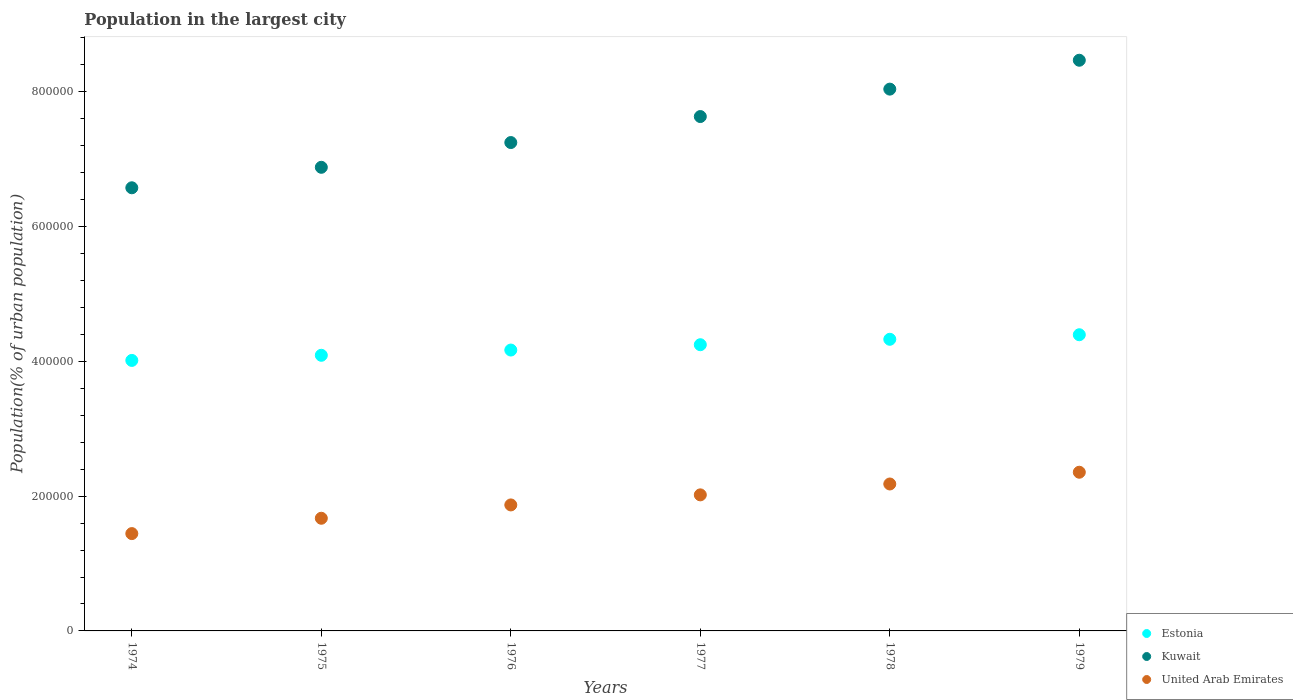How many different coloured dotlines are there?
Your response must be concise. 3. What is the population in the largest city in Kuwait in 1976?
Provide a succinct answer. 7.25e+05. Across all years, what is the maximum population in the largest city in Estonia?
Offer a very short reply. 4.40e+05. Across all years, what is the minimum population in the largest city in Estonia?
Your response must be concise. 4.01e+05. In which year was the population in the largest city in Kuwait maximum?
Offer a terse response. 1979. In which year was the population in the largest city in Estonia minimum?
Ensure brevity in your answer.  1974. What is the total population in the largest city in Estonia in the graph?
Your response must be concise. 2.52e+06. What is the difference between the population in the largest city in United Arab Emirates in 1976 and that in 1978?
Give a very brief answer. -3.11e+04. What is the difference between the population in the largest city in Kuwait in 1978 and the population in the largest city in United Arab Emirates in 1976?
Give a very brief answer. 6.17e+05. What is the average population in the largest city in Estonia per year?
Offer a very short reply. 4.21e+05. In the year 1979, what is the difference between the population in the largest city in Estonia and population in the largest city in United Arab Emirates?
Ensure brevity in your answer.  2.04e+05. In how many years, is the population in the largest city in Estonia greater than 200000 %?
Keep it short and to the point. 6. What is the ratio of the population in the largest city in Kuwait in 1976 to that in 1977?
Give a very brief answer. 0.95. What is the difference between the highest and the second highest population in the largest city in Estonia?
Offer a terse response. 6750. What is the difference between the highest and the lowest population in the largest city in Kuwait?
Provide a short and direct response. 1.89e+05. In how many years, is the population in the largest city in United Arab Emirates greater than the average population in the largest city in United Arab Emirates taken over all years?
Your response must be concise. 3. Is it the case that in every year, the sum of the population in the largest city in Kuwait and population in the largest city in United Arab Emirates  is greater than the population in the largest city in Estonia?
Your answer should be compact. Yes. Does the population in the largest city in Estonia monotonically increase over the years?
Your answer should be very brief. Yes. Is the population in the largest city in Kuwait strictly greater than the population in the largest city in Estonia over the years?
Your answer should be compact. Yes. How many dotlines are there?
Make the answer very short. 3. What is the difference between two consecutive major ticks on the Y-axis?
Give a very brief answer. 2.00e+05. Does the graph contain any zero values?
Keep it short and to the point. No. Does the graph contain grids?
Your answer should be compact. No. How are the legend labels stacked?
Ensure brevity in your answer.  Vertical. What is the title of the graph?
Keep it short and to the point. Population in the largest city. Does "Switzerland" appear as one of the legend labels in the graph?
Your answer should be compact. No. What is the label or title of the X-axis?
Offer a very short reply. Years. What is the label or title of the Y-axis?
Offer a very short reply. Population(% of urban population). What is the Population(% of urban population) in Estonia in 1974?
Make the answer very short. 4.01e+05. What is the Population(% of urban population) of Kuwait in 1974?
Your answer should be compact. 6.58e+05. What is the Population(% of urban population) of United Arab Emirates in 1974?
Give a very brief answer. 1.44e+05. What is the Population(% of urban population) in Estonia in 1975?
Give a very brief answer. 4.09e+05. What is the Population(% of urban population) of Kuwait in 1975?
Offer a terse response. 6.88e+05. What is the Population(% of urban population) in United Arab Emirates in 1975?
Give a very brief answer. 1.67e+05. What is the Population(% of urban population) in Estonia in 1976?
Offer a very short reply. 4.17e+05. What is the Population(% of urban population) in Kuwait in 1976?
Ensure brevity in your answer.  7.25e+05. What is the Population(% of urban population) of United Arab Emirates in 1976?
Offer a terse response. 1.87e+05. What is the Population(% of urban population) in Estonia in 1977?
Give a very brief answer. 4.25e+05. What is the Population(% of urban population) of Kuwait in 1977?
Provide a short and direct response. 7.63e+05. What is the Population(% of urban population) of United Arab Emirates in 1977?
Give a very brief answer. 2.02e+05. What is the Population(% of urban population) of Estonia in 1978?
Your answer should be compact. 4.33e+05. What is the Population(% of urban population) of Kuwait in 1978?
Offer a terse response. 8.04e+05. What is the Population(% of urban population) of United Arab Emirates in 1978?
Your answer should be very brief. 2.18e+05. What is the Population(% of urban population) in Estonia in 1979?
Ensure brevity in your answer.  4.40e+05. What is the Population(% of urban population) of Kuwait in 1979?
Make the answer very short. 8.47e+05. What is the Population(% of urban population) of United Arab Emirates in 1979?
Your response must be concise. 2.36e+05. Across all years, what is the maximum Population(% of urban population) of Estonia?
Your response must be concise. 4.40e+05. Across all years, what is the maximum Population(% of urban population) in Kuwait?
Provide a short and direct response. 8.47e+05. Across all years, what is the maximum Population(% of urban population) of United Arab Emirates?
Provide a short and direct response. 2.36e+05. Across all years, what is the minimum Population(% of urban population) of Estonia?
Provide a succinct answer. 4.01e+05. Across all years, what is the minimum Population(% of urban population) of Kuwait?
Ensure brevity in your answer.  6.58e+05. Across all years, what is the minimum Population(% of urban population) of United Arab Emirates?
Make the answer very short. 1.44e+05. What is the total Population(% of urban population) of Estonia in the graph?
Your answer should be very brief. 2.52e+06. What is the total Population(% of urban population) of Kuwait in the graph?
Make the answer very short. 4.48e+06. What is the total Population(% of urban population) of United Arab Emirates in the graph?
Make the answer very short. 1.15e+06. What is the difference between the Population(% of urban population) of Estonia in 1974 and that in 1975?
Your answer should be very brief. -7622. What is the difference between the Population(% of urban population) in Kuwait in 1974 and that in 1975?
Offer a very short reply. -3.04e+04. What is the difference between the Population(% of urban population) in United Arab Emirates in 1974 and that in 1975?
Provide a short and direct response. -2.28e+04. What is the difference between the Population(% of urban population) in Estonia in 1974 and that in 1976?
Give a very brief answer. -1.54e+04. What is the difference between the Population(% of urban population) in Kuwait in 1974 and that in 1976?
Your response must be concise. -6.71e+04. What is the difference between the Population(% of urban population) of United Arab Emirates in 1974 and that in 1976?
Offer a very short reply. -4.25e+04. What is the difference between the Population(% of urban population) of Estonia in 1974 and that in 1977?
Keep it short and to the point. -2.33e+04. What is the difference between the Population(% of urban population) of Kuwait in 1974 and that in 1977?
Provide a short and direct response. -1.06e+05. What is the difference between the Population(% of urban population) in United Arab Emirates in 1974 and that in 1977?
Make the answer very short. -5.75e+04. What is the difference between the Population(% of urban population) in Estonia in 1974 and that in 1978?
Ensure brevity in your answer.  -3.14e+04. What is the difference between the Population(% of urban population) in Kuwait in 1974 and that in 1978?
Offer a very short reply. -1.46e+05. What is the difference between the Population(% of urban population) in United Arab Emirates in 1974 and that in 1978?
Offer a very short reply. -7.36e+04. What is the difference between the Population(% of urban population) of Estonia in 1974 and that in 1979?
Give a very brief answer. -3.81e+04. What is the difference between the Population(% of urban population) of Kuwait in 1974 and that in 1979?
Your response must be concise. -1.89e+05. What is the difference between the Population(% of urban population) in United Arab Emirates in 1974 and that in 1979?
Provide a succinct answer. -9.11e+04. What is the difference between the Population(% of urban population) in Estonia in 1975 and that in 1976?
Offer a very short reply. -7777. What is the difference between the Population(% of urban population) in Kuwait in 1975 and that in 1976?
Provide a short and direct response. -3.67e+04. What is the difference between the Population(% of urban population) of United Arab Emirates in 1975 and that in 1976?
Your answer should be very brief. -1.98e+04. What is the difference between the Population(% of urban population) in Estonia in 1975 and that in 1977?
Provide a succinct answer. -1.57e+04. What is the difference between the Population(% of urban population) in Kuwait in 1975 and that in 1977?
Your response must be concise. -7.53e+04. What is the difference between the Population(% of urban population) of United Arab Emirates in 1975 and that in 1977?
Make the answer very short. -3.47e+04. What is the difference between the Population(% of urban population) of Estonia in 1975 and that in 1978?
Your answer should be very brief. -2.37e+04. What is the difference between the Population(% of urban population) of Kuwait in 1975 and that in 1978?
Offer a very short reply. -1.16e+05. What is the difference between the Population(% of urban population) in United Arab Emirates in 1975 and that in 1978?
Keep it short and to the point. -5.09e+04. What is the difference between the Population(% of urban population) in Estonia in 1975 and that in 1979?
Offer a very short reply. -3.05e+04. What is the difference between the Population(% of urban population) of Kuwait in 1975 and that in 1979?
Offer a terse response. -1.59e+05. What is the difference between the Population(% of urban population) in United Arab Emirates in 1975 and that in 1979?
Your answer should be compact. -6.83e+04. What is the difference between the Population(% of urban population) of Estonia in 1976 and that in 1977?
Provide a succinct answer. -7904. What is the difference between the Population(% of urban population) in Kuwait in 1976 and that in 1977?
Your response must be concise. -3.86e+04. What is the difference between the Population(% of urban population) in United Arab Emirates in 1976 and that in 1977?
Keep it short and to the point. -1.49e+04. What is the difference between the Population(% of urban population) in Estonia in 1976 and that in 1978?
Offer a terse response. -1.60e+04. What is the difference between the Population(% of urban population) of Kuwait in 1976 and that in 1978?
Provide a short and direct response. -7.93e+04. What is the difference between the Population(% of urban population) of United Arab Emirates in 1976 and that in 1978?
Your answer should be very brief. -3.11e+04. What is the difference between the Population(% of urban population) in Estonia in 1976 and that in 1979?
Offer a very short reply. -2.27e+04. What is the difference between the Population(% of urban population) in Kuwait in 1976 and that in 1979?
Ensure brevity in your answer.  -1.22e+05. What is the difference between the Population(% of urban population) in United Arab Emirates in 1976 and that in 1979?
Ensure brevity in your answer.  -4.85e+04. What is the difference between the Population(% of urban population) in Estonia in 1977 and that in 1978?
Offer a very short reply. -8064. What is the difference between the Population(% of urban population) of Kuwait in 1977 and that in 1978?
Provide a short and direct response. -4.07e+04. What is the difference between the Population(% of urban population) in United Arab Emirates in 1977 and that in 1978?
Your response must be concise. -1.61e+04. What is the difference between the Population(% of urban population) in Estonia in 1977 and that in 1979?
Provide a succinct answer. -1.48e+04. What is the difference between the Population(% of urban population) of Kuwait in 1977 and that in 1979?
Provide a succinct answer. -8.36e+04. What is the difference between the Population(% of urban population) of United Arab Emirates in 1977 and that in 1979?
Your answer should be very brief. -3.36e+04. What is the difference between the Population(% of urban population) in Estonia in 1978 and that in 1979?
Your answer should be very brief. -6750. What is the difference between the Population(% of urban population) of Kuwait in 1978 and that in 1979?
Keep it short and to the point. -4.29e+04. What is the difference between the Population(% of urban population) in United Arab Emirates in 1978 and that in 1979?
Offer a very short reply. -1.74e+04. What is the difference between the Population(% of urban population) in Estonia in 1974 and the Population(% of urban population) in Kuwait in 1975?
Make the answer very short. -2.87e+05. What is the difference between the Population(% of urban population) of Estonia in 1974 and the Population(% of urban population) of United Arab Emirates in 1975?
Your answer should be compact. 2.34e+05. What is the difference between the Population(% of urban population) of Kuwait in 1974 and the Population(% of urban population) of United Arab Emirates in 1975?
Your answer should be very brief. 4.90e+05. What is the difference between the Population(% of urban population) of Estonia in 1974 and the Population(% of urban population) of Kuwait in 1976?
Your answer should be very brief. -3.23e+05. What is the difference between the Population(% of urban population) in Estonia in 1974 and the Population(% of urban population) in United Arab Emirates in 1976?
Your response must be concise. 2.14e+05. What is the difference between the Population(% of urban population) in Kuwait in 1974 and the Population(% of urban population) in United Arab Emirates in 1976?
Offer a terse response. 4.71e+05. What is the difference between the Population(% of urban population) of Estonia in 1974 and the Population(% of urban population) of Kuwait in 1977?
Your answer should be very brief. -3.62e+05. What is the difference between the Population(% of urban population) in Estonia in 1974 and the Population(% of urban population) in United Arab Emirates in 1977?
Give a very brief answer. 2.00e+05. What is the difference between the Population(% of urban population) in Kuwait in 1974 and the Population(% of urban population) in United Arab Emirates in 1977?
Offer a very short reply. 4.56e+05. What is the difference between the Population(% of urban population) in Estonia in 1974 and the Population(% of urban population) in Kuwait in 1978?
Your answer should be compact. -4.03e+05. What is the difference between the Population(% of urban population) in Estonia in 1974 and the Population(% of urban population) in United Arab Emirates in 1978?
Ensure brevity in your answer.  1.83e+05. What is the difference between the Population(% of urban population) in Kuwait in 1974 and the Population(% of urban population) in United Arab Emirates in 1978?
Provide a succinct answer. 4.40e+05. What is the difference between the Population(% of urban population) of Estonia in 1974 and the Population(% of urban population) of Kuwait in 1979?
Your response must be concise. -4.45e+05. What is the difference between the Population(% of urban population) in Estonia in 1974 and the Population(% of urban population) in United Arab Emirates in 1979?
Keep it short and to the point. 1.66e+05. What is the difference between the Population(% of urban population) in Kuwait in 1974 and the Population(% of urban population) in United Arab Emirates in 1979?
Keep it short and to the point. 4.22e+05. What is the difference between the Population(% of urban population) of Estonia in 1975 and the Population(% of urban population) of Kuwait in 1976?
Give a very brief answer. -3.16e+05. What is the difference between the Population(% of urban population) in Estonia in 1975 and the Population(% of urban population) in United Arab Emirates in 1976?
Your response must be concise. 2.22e+05. What is the difference between the Population(% of urban population) in Kuwait in 1975 and the Population(% of urban population) in United Arab Emirates in 1976?
Offer a terse response. 5.01e+05. What is the difference between the Population(% of urban population) in Estonia in 1975 and the Population(% of urban population) in Kuwait in 1977?
Your answer should be compact. -3.54e+05. What is the difference between the Population(% of urban population) in Estonia in 1975 and the Population(% of urban population) in United Arab Emirates in 1977?
Your answer should be very brief. 2.07e+05. What is the difference between the Population(% of urban population) in Kuwait in 1975 and the Population(% of urban population) in United Arab Emirates in 1977?
Provide a short and direct response. 4.86e+05. What is the difference between the Population(% of urban population) of Estonia in 1975 and the Population(% of urban population) of Kuwait in 1978?
Give a very brief answer. -3.95e+05. What is the difference between the Population(% of urban population) in Estonia in 1975 and the Population(% of urban population) in United Arab Emirates in 1978?
Your answer should be very brief. 1.91e+05. What is the difference between the Population(% of urban population) of Kuwait in 1975 and the Population(% of urban population) of United Arab Emirates in 1978?
Your answer should be very brief. 4.70e+05. What is the difference between the Population(% of urban population) of Estonia in 1975 and the Population(% of urban population) of Kuwait in 1979?
Provide a succinct answer. -4.38e+05. What is the difference between the Population(% of urban population) in Estonia in 1975 and the Population(% of urban population) in United Arab Emirates in 1979?
Offer a terse response. 1.74e+05. What is the difference between the Population(% of urban population) in Kuwait in 1975 and the Population(% of urban population) in United Arab Emirates in 1979?
Keep it short and to the point. 4.53e+05. What is the difference between the Population(% of urban population) in Estonia in 1976 and the Population(% of urban population) in Kuwait in 1977?
Offer a terse response. -3.47e+05. What is the difference between the Population(% of urban population) of Estonia in 1976 and the Population(% of urban population) of United Arab Emirates in 1977?
Offer a very short reply. 2.15e+05. What is the difference between the Population(% of urban population) of Kuwait in 1976 and the Population(% of urban population) of United Arab Emirates in 1977?
Ensure brevity in your answer.  5.23e+05. What is the difference between the Population(% of urban population) in Estonia in 1976 and the Population(% of urban population) in Kuwait in 1978?
Keep it short and to the point. -3.87e+05. What is the difference between the Population(% of urban population) of Estonia in 1976 and the Population(% of urban population) of United Arab Emirates in 1978?
Provide a short and direct response. 1.99e+05. What is the difference between the Population(% of urban population) in Kuwait in 1976 and the Population(% of urban population) in United Arab Emirates in 1978?
Provide a short and direct response. 5.07e+05. What is the difference between the Population(% of urban population) of Estonia in 1976 and the Population(% of urban population) of Kuwait in 1979?
Provide a short and direct response. -4.30e+05. What is the difference between the Population(% of urban population) of Estonia in 1976 and the Population(% of urban population) of United Arab Emirates in 1979?
Offer a very short reply. 1.81e+05. What is the difference between the Population(% of urban population) of Kuwait in 1976 and the Population(% of urban population) of United Arab Emirates in 1979?
Your answer should be compact. 4.89e+05. What is the difference between the Population(% of urban population) in Estonia in 1977 and the Population(% of urban population) in Kuwait in 1978?
Your response must be concise. -3.79e+05. What is the difference between the Population(% of urban population) in Estonia in 1977 and the Population(% of urban population) in United Arab Emirates in 1978?
Your response must be concise. 2.07e+05. What is the difference between the Population(% of urban population) in Kuwait in 1977 and the Population(% of urban population) in United Arab Emirates in 1978?
Your answer should be compact. 5.45e+05. What is the difference between the Population(% of urban population) in Estonia in 1977 and the Population(% of urban population) in Kuwait in 1979?
Give a very brief answer. -4.22e+05. What is the difference between the Population(% of urban population) of Estonia in 1977 and the Population(% of urban population) of United Arab Emirates in 1979?
Your answer should be very brief. 1.89e+05. What is the difference between the Population(% of urban population) of Kuwait in 1977 and the Population(% of urban population) of United Arab Emirates in 1979?
Offer a terse response. 5.28e+05. What is the difference between the Population(% of urban population) of Estonia in 1978 and the Population(% of urban population) of Kuwait in 1979?
Your answer should be compact. -4.14e+05. What is the difference between the Population(% of urban population) of Estonia in 1978 and the Population(% of urban population) of United Arab Emirates in 1979?
Keep it short and to the point. 1.97e+05. What is the difference between the Population(% of urban population) in Kuwait in 1978 and the Population(% of urban population) in United Arab Emirates in 1979?
Provide a short and direct response. 5.69e+05. What is the average Population(% of urban population) in Estonia per year?
Provide a short and direct response. 4.21e+05. What is the average Population(% of urban population) in Kuwait per year?
Your answer should be compact. 7.47e+05. What is the average Population(% of urban population) of United Arab Emirates per year?
Your answer should be very brief. 1.92e+05. In the year 1974, what is the difference between the Population(% of urban population) in Estonia and Population(% of urban population) in Kuwait?
Offer a terse response. -2.56e+05. In the year 1974, what is the difference between the Population(% of urban population) in Estonia and Population(% of urban population) in United Arab Emirates?
Provide a succinct answer. 2.57e+05. In the year 1974, what is the difference between the Population(% of urban population) of Kuwait and Population(% of urban population) of United Arab Emirates?
Provide a short and direct response. 5.13e+05. In the year 1975, what is the difference between the Population(% of urban population) of Estonia and Population(% of urban population) of Kuwait?
Your response must be concise. -2.79e+05. In the year 1975, what is the difference between the Population(% of urban population) of Estonia and Population(% of urban population) of United Arab Emirates?
Your answer should be very brief. 2.42e+05. In the year 1975, what is the difference between the Population(% of urban population) in Kuwait and Population(% of urban population) in United Arab Emirates?
Offer a very short reply. 5.21e+05. In the year 1976, what is the difference between the Population(% of urban population) of Estonia and Population(% of urban population) of Kuwait?
Offer a very short reply. -3.08e+05. In the year 1976, what is the difference between the Population(% of urban population) in Estonia and Population(% of urban population) in United Arab Emirates?
Provide a succinct answer. 2.30e+05. In the year 1976, what is the difference between the Population(% of urban population) in Kuwait and Population(% of urban population) in United Arab Emirates?
Make the answer very short. 5.38e+05. In the year 1977, what is the difference between the Population(% of urban population) of Estonia and Population(% of urban population) of Kuwait?
Offer a very short reply. -3.39e+05. In the year 1977, what is the difference between the Population(% of urban population) of Estonia and Population(% of urban population) of United Arab Emirates?
Provide a short and direct response. 2.23e+05. In the year 1977, what is the difference between the Population(% of urban population) of Kuwait and Population(% of urban population) of United Arab Emirates?
Keep it short and to the point. 5.61e+05. In the year 1978, what is the difference between the Population(% of urban population) of Estonia and Population(% of urban population) of Kuwait?
Ensure brevity in your answer.  -3.71e+05. In the year 1978, what is the difference between the Population(% of urban population) of Estonia and Population(% of urban population) of United Arab Emirates?
Your response must be concise. 2.15e+05. In the year 1978, what is the difference between the Population(% of urban population) in Kuwait and Population(% of urban population) in United Arab Emirates?
Your answer should be very brief. 5.86e+05. In the year 1979, what is the difference between the Population(% of urban population) in Estonia and Population(% of urban population) in Kuwait?
Your response must be concise. -4.07e+05. In the year 1979, what is the difference between the Population(% of urban population) in Estonia and Population(% of urban population) in United Arab Emirates?
Provide a succinct answer. 2.04e+05. In the year 1979, what is the difference between the Population(% of urban population) in Kuwait and Population(% of urban population) in United Arab Emirates?
Provide a short and direct response. 6.11e+05. What is the ratio of the Population(% of urban population) of Estonia in 1974 to that in 1975?
Give a very brief answer. 0.98. What is the ratio of the Population(% of urban population) of Kuwait in 1974 to that in 1975?
Make the answer very short. 0.96. What is the ratio of the Population(% of urban population) in United Arab Emirates in 1974 to that in 1975?
Make the answer very short. 0.86. What is the ratio of the Population(% of urban population) in Estonia in 1974 to that in 1976?
Your response must be concise. 0.96. What is the ratio of the Population(% of urban population) in Kuwait in 1974 to that in 1976?
Your answer should be compact. 0.91. What is the ratio of the Population(% of urban population) in United Arab Emirates in 1974 to that in 1976?
Keep it short and to the point. 0.77. What is the ratio of the Population(% of urban population) in Estonia in 1974 to that in 1977?
Give a very brief answer. 0.95. What is the ratio of the Population(% of urban population) of Kuwait in 1974 to that in 1977?
Provide a short and direct response. 0.86. What is the ratio of the Population(% of urban population) in United Arab Emirates in 1974 to that in 1977?
Keep it short and to the point. 0.72. What is the ratio of the Population(% of urban population) of Estonia in 1974 to that in 1978?
Ensure brevity in your answer.  0.93. What is the ratio of the Population(% of urban population) in Kuwait in 1974 to that in 1978?
Offer a terse response. 0.82. What is the ratio of the Population(% of urban population) of United Arab Emirates in 1974 to that in 1978?
Offer a very short reply. 0.66. What is the ratio of the Population(% of urban population) in Estonia in 1974 to that in 1979?
Ensure brevity in your answer.  0.91. What is the ratio of the Population(% of urban population) in Kuwait in 1974 to that in 1979?
Your answer should be very brief. 0.78. What is the ratio of the Population(% of urban population) of United Arab Emirates in 1974 to that in 1979?
Offer a terse response. 0.61. What is the ratio of the Population(% of urban population) of Estonia in 1975 to that in 1976?
Ensure brevity in your answer.  0.98. What is the ratio of the Population(% of urban population) in Kuwait in 1975 to that in 1976?
Ensure brevity in your answer.  0.95. What is the ratio of the Population(% of urban population) in United Arab Emirates in 1975 to that in 1976?
Ensure brevity in your answer.  0.89. What is the ratio of the Population(% of urban population) of Estonia in 1975 to that in 1977?
Your answer should be compact. 0.96. What is the ratio of the Population(% of urban population) in Kuwait in 1975 to that in 1977?
Make the answer very short. 0.9. What is the ratio of the Population(% of urban population) of United Arab Emirates in 1975 to that in 1977?
Give a very brief answer. 0.83. What is the ratio of the Population(% of urban population) of Estonia in 1975 to that in 1978?
Give a very brief answer. 0.95. What is the ratio of the Population(% of urban population) in Kuwait in 1975 to that in 1978?
Offer a very short reply. 0.86. What is the ratio of the Population(% of urban population) of United Arab Emirates in 1975 to that in 1978?
Your answer should be very brief. 0.77. What is the ratio of the Population(% of urban population) of Estonia in 1975 to that in 1979?
Keep it short and to the point. 0.93. What is the ratio of the Population(% of urban population) of Kuwait in 1975 to that in 1979?
Make the answer very short. 0.81. What is the ratio of the Population(% of urban population) of United Arab Emirates in 1975 to that in 1979?
Provide a short and direct response. 0.71. What is the ratio of the Population(% of urban population) in Estonia in 1976 to that in 1977?
Your answer should be very brief. 0.98. What is the ratio of the Population(% of urban population) in Kuwait in 1976 to that in 1977?
Make the answer very short. 0.95. What is the ratio of the Population(% of urban population) in United Arab Emirates in 1976 to that in 1977?
Offer a very short reply. 0.93. What is the ratio of the Population(% of urban population) in Estonia in 1976 to that in 1978?
Provide a short and direct response. 0.96. What is the ratio of the Population(% of urban population) in Kuwait in 1976 to that in 1978?
Provide a succinct answer. 0.9. What is the ratio of the Population(% of urban population) of United Arab Emirates in 1976 to that in 1978?
Your answer should be compact. 0.86. What is the ratio of the Population(% of urban population) of Estonia in 1976 to that in 1979?
Offer a very short reply. 0.95. What is the ratio of the Population(% of urban population) of Kuwait in 1976 to that in 1979?
Your response must be concise. 0.86. What is the ratio of the Population(% of urban population) of United Arab Emirates in 1976 to that in 1979?
Offer a terse response. 0.79. What is the ratio of the Population(% of urban population) in Estonia in 1977 to that in 1978?
Make the answer very short. 0.98. What is the ratio of the Population(% of urban population) in Kuwait in 1977 to that in 1978?
Your answer should be compact. 0.95. What is the ratio of the Population(% of urban population) of United Arab Emirates in 1977 to that in 1978?
Give a very brief answer. 0.93. What is the ratio of the Population(% of urban population) of Estonia in 1977 to that in 1979?
Your answer should be compact. 0.97. What is the ratio of the Population(% of urban population) in Kuwait in 1977 to that in 1979?
Your answer should be very brief. 0.9. What is the ratio of the Population(% of urban population) of United Arab Emirates in 1977 to that in 1979?
Your answer should be compact. 0.86. What is the ratio of the Population(% of urban population) in Estonia in 1978 to that in 1979?
Your answer should be very brief. 0.98. What is the ratio of the Population(% of urban population) of Kuwait in 1978 to that in 1979?
Give a very brief answer. 0.95. What is the ratio of the Population(% of urban population) in United Arab Emirates in 1978 to that in 1979?
Provide a succinct answer. 0.93. What is the difference between the highest and the second highest Population(% of urban population) in Estonia?
Make the answer very short. 6750. What is the difference between the highest and the second highest Population(% of urban population) in Kuwait?
Keep it short and to the point. 4.29e+04. What is the difference between the highest and the second highest Population(% of urban population) in United Arab Emirates?
Provide a succinct answer. 1.74e+04. What is the difference between the highest and the lowest Population(% of urban population) of Estonia?
Ensure brevity in your answer.  3.81e+04. What is the difference between the highest and the lowest Population(% of urban population) of Kuwait?
Make the answer very short. 1.89e+05. What is the difference between the highest and the lowest Population(% of urban population) in United Arab Emirates?
Give a very brief answer. 9.11e+04. 